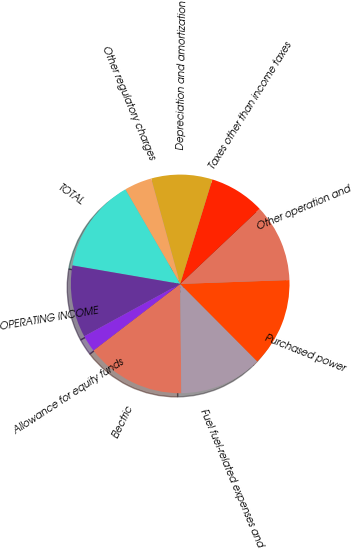<chart> <loc_0><loc_0><loc_500><loc_500><pie_chart><fcel>Electric<fcel>Fuel fuel-related expenses and<fcel>Purchased power<fcel>Other operation and<fcel>Taxes other than income taxes<fcel>Depreciation and amortization<fcel>Other regulatory charges<fcel>TOTAL<fcel>OPERATING INCOME<fcel>Allowance for equity funds<nl><fcel>14.75%<fcel>12.29%<fcel>13.11%<fcel>11.48%<fcel>8.2%<fcel>9.02%<fcel>4.1%<fcel>13.93%<fcel>10.66%<fcel>2.46%<nl></chart> 